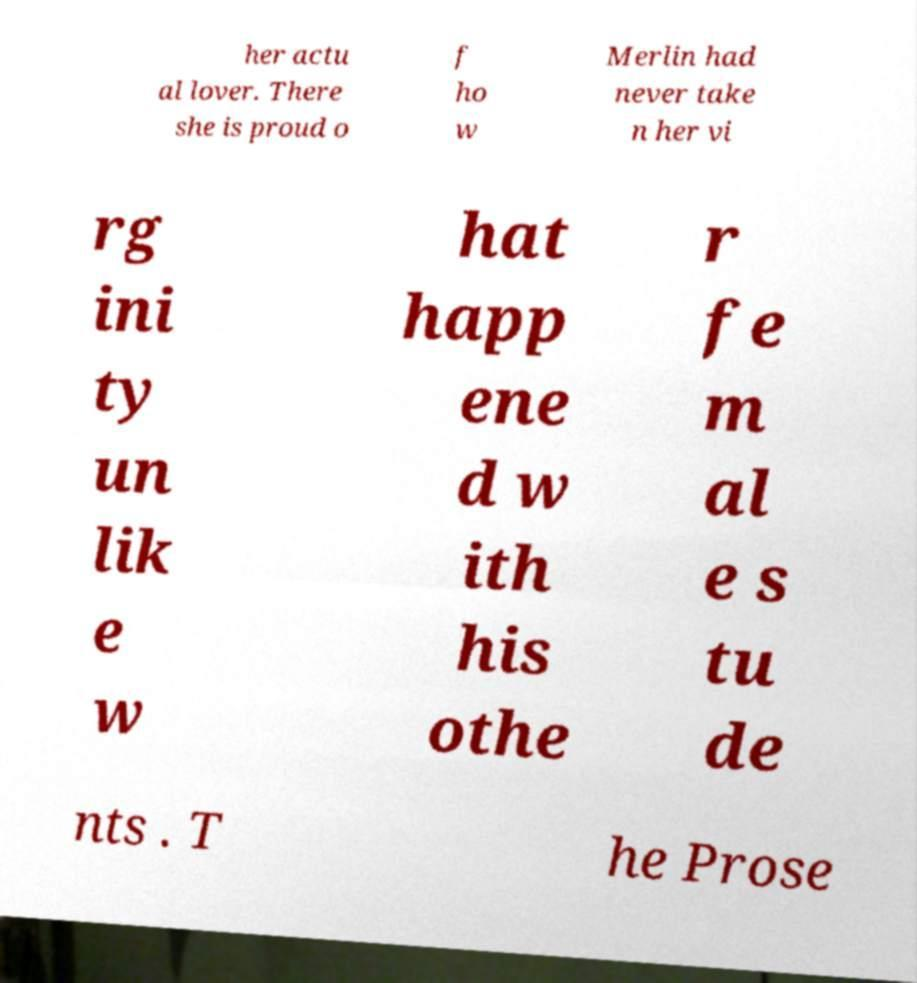Please read and relay the text visible in this image. What does it say? her actu al lover. There she is proud o f ho w Merlin had never take n her vi rg ini ty un lik e w hat happ ene d w ith his othe r fe m al e s tu de nts . T he Prose 